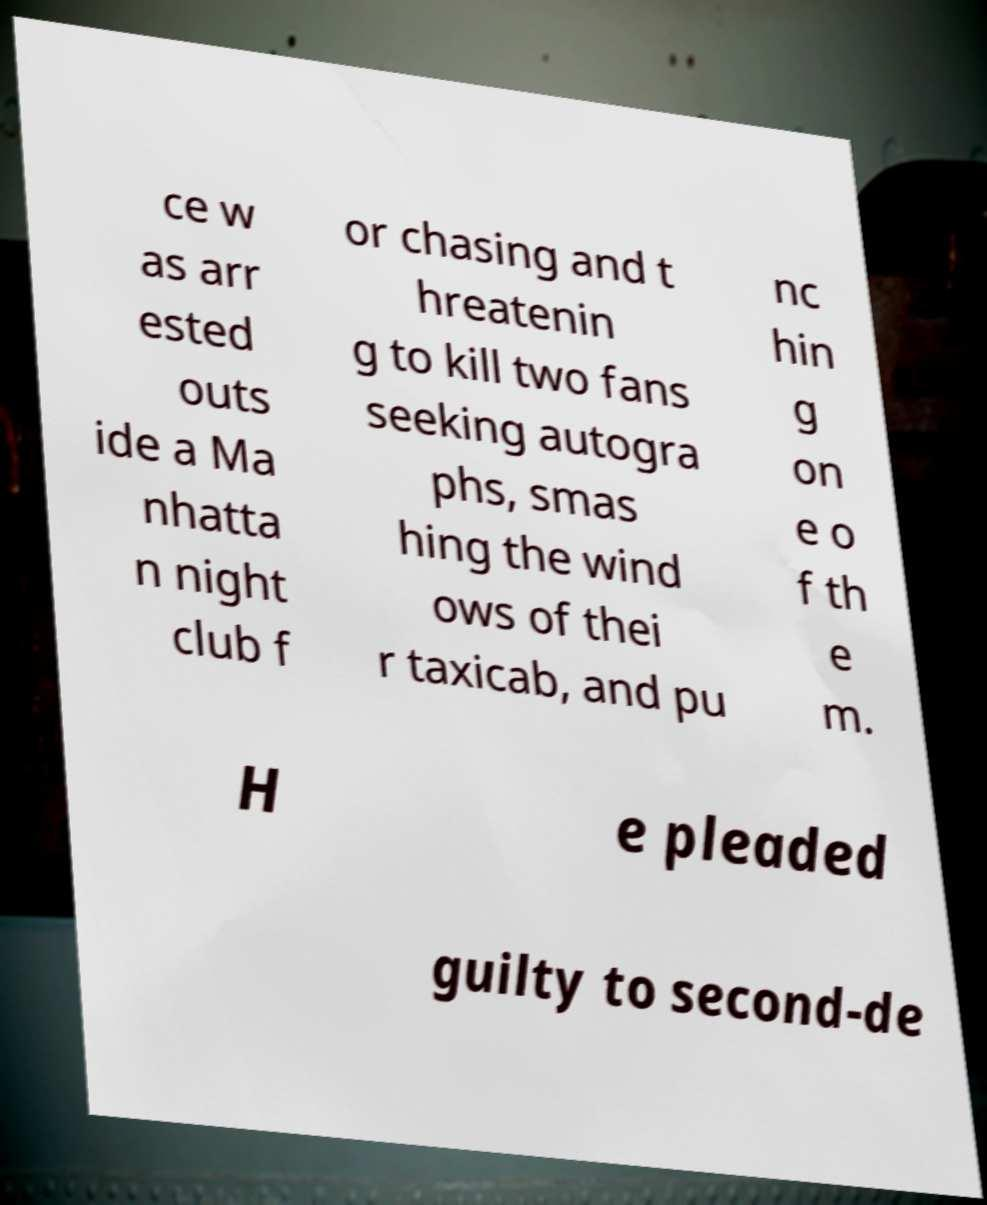Please identify and transcribe the text found in this image. ce w as arr ested outs ide a Ma nhatta n night club f or chasing and t hreatenin g to kill two fans seeking autogra phs, smas hing the wind ows of thei r taxicab, and pu nc hin g on e o f th e m. H e pleaded guilty to second-de 